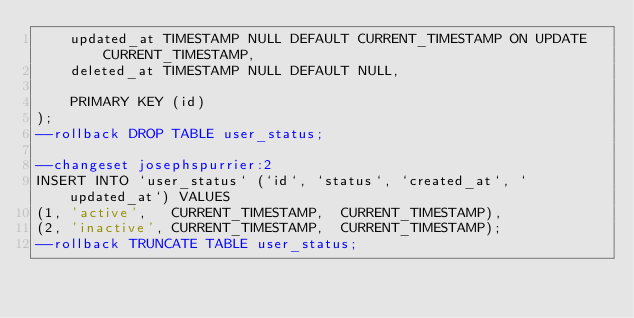<code> <loc_0><loc_0><loc_500><loc_500><_SQL_>    updated_at TIMESTAMP NULL DEFAULT CURRENT_TIMESTAMP ON UPDATE CURRENT_TIMESTAMP,
    deleted_at TIMESTAMP NULL DEFAULT NULL,
    
    PRIMARY KEY (id)
);
--rollback DROP TABLE user_status;

--changeset josephspurrier:2
INSERT INTO `user_status` (`id`, `status`, `created_at`, `updated_at`) VALUES
(1, 'active',   CURRENT_TIMESTAMP,  CURRENT_TIMESTAMP),
(2, 'inactive', CURRENT_TIMESTAMP,  CURRENT_TIMESTAMP);
--rollback TRUNCATE TABLE user_status;</code> 